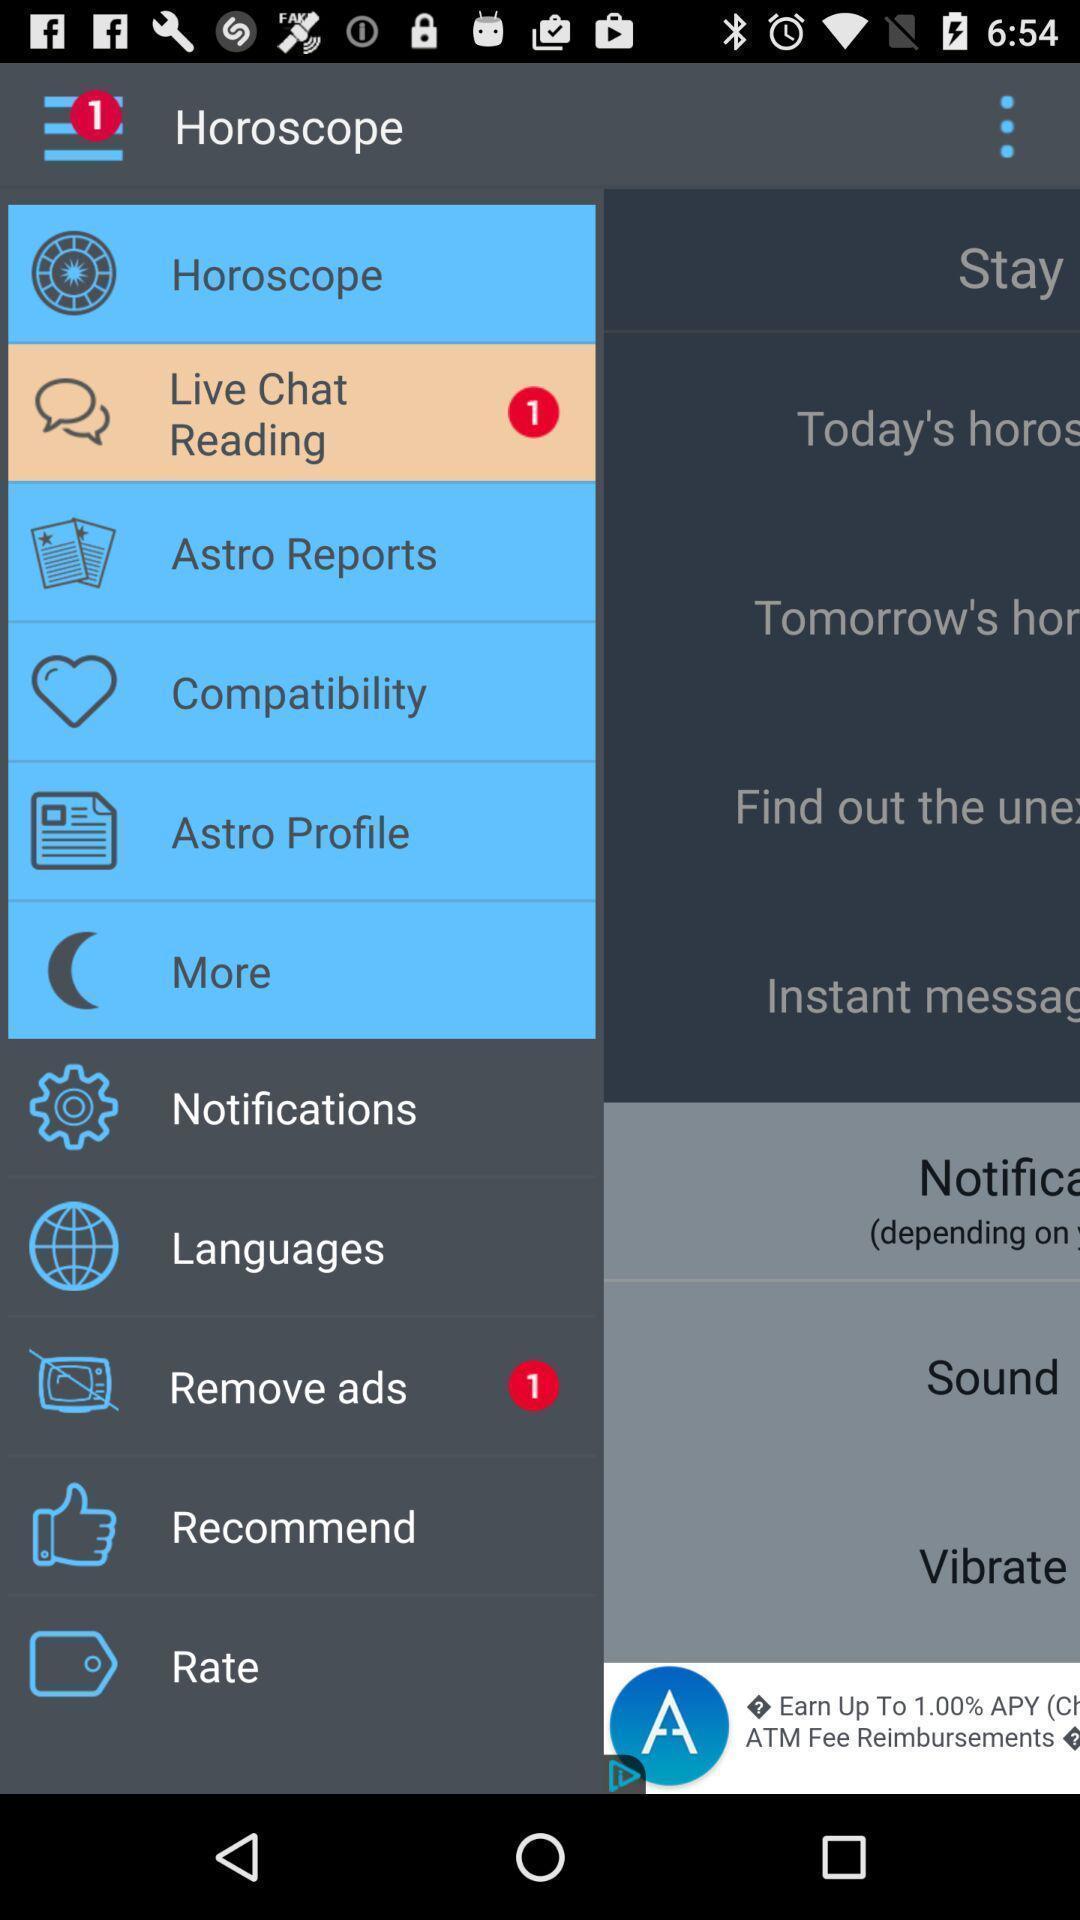Summarize the main components in this picture. Pop up notification of different options of the app. 